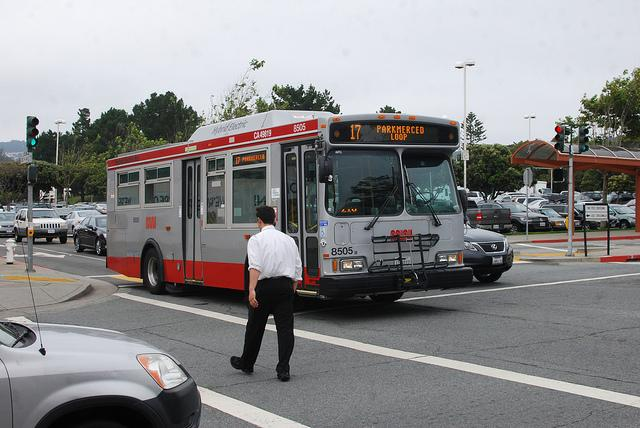After making one full circuit of their route starting from here where will this bus return?

Choices:
A) next city
B) mexico
C) here
D) depot here 